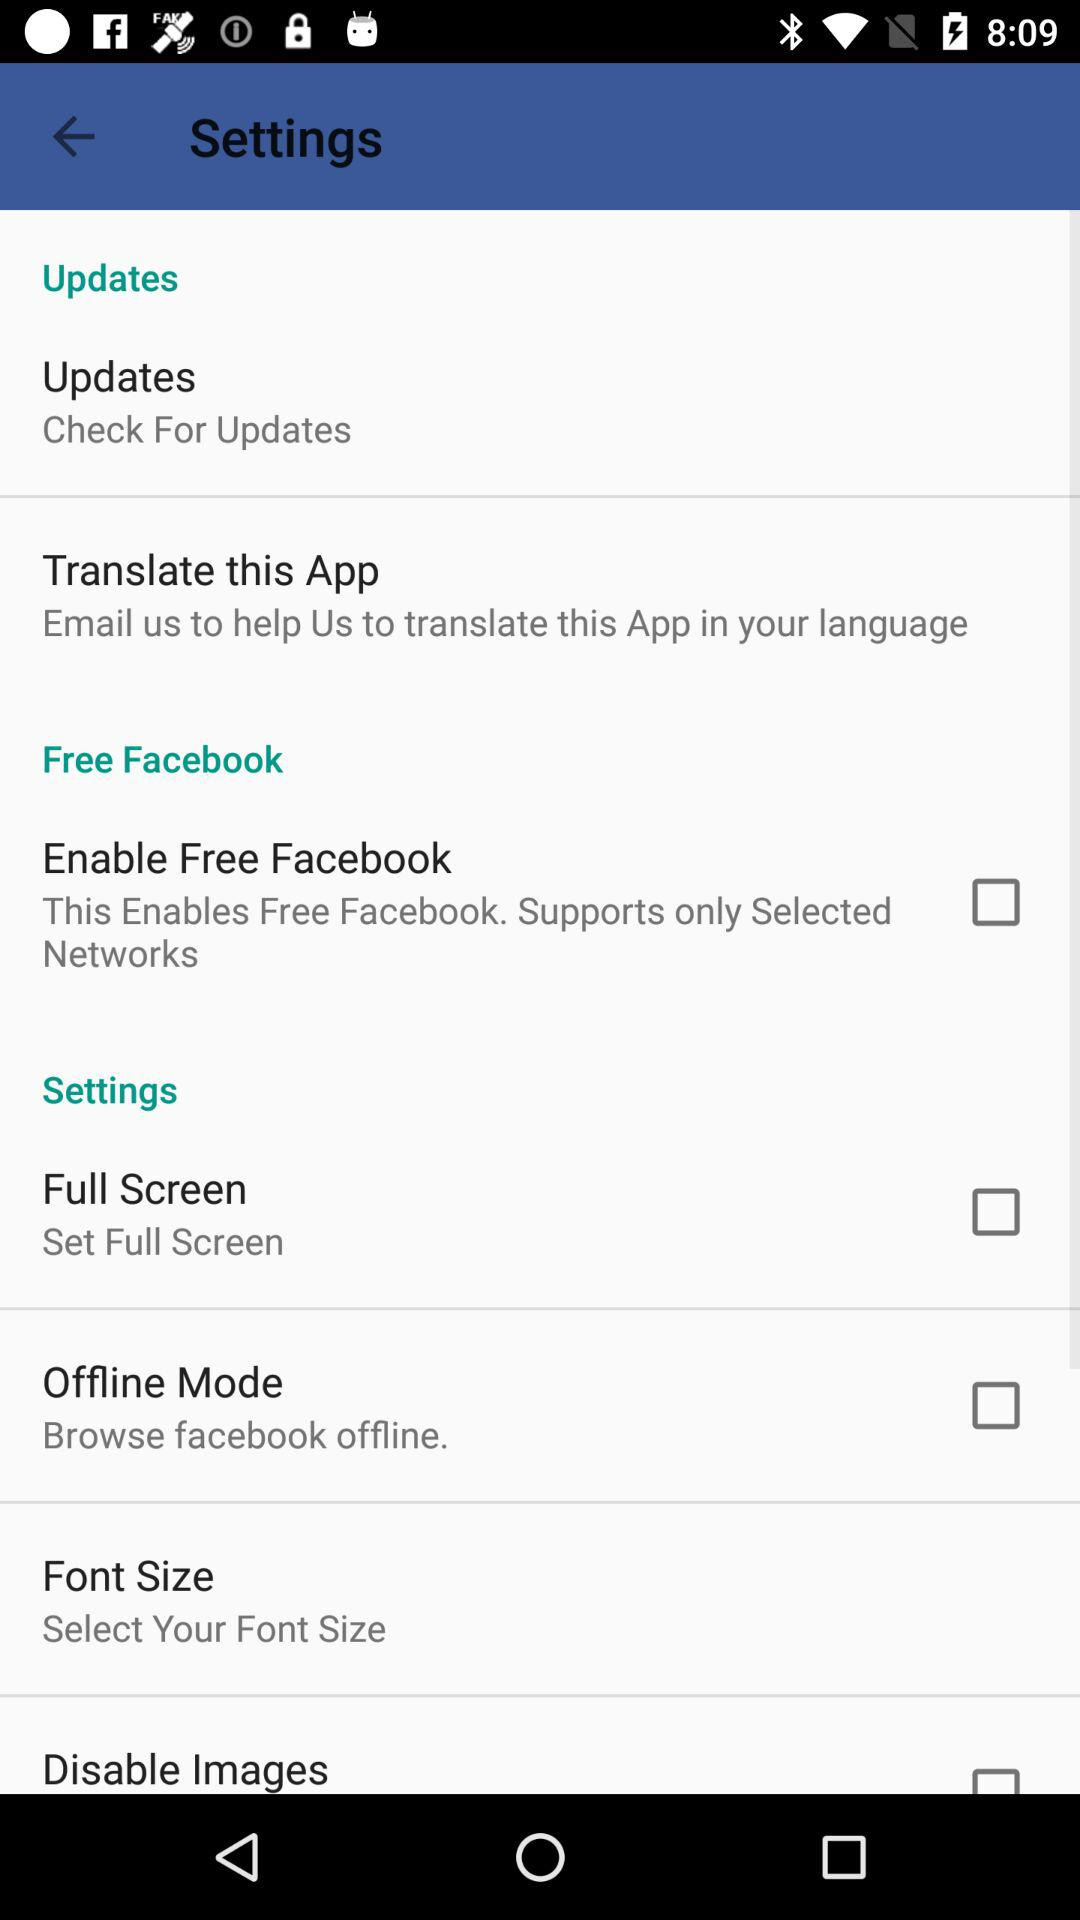What is the status of "Enable Free Facebook"? The status of "Enable Free Facebook" is "off". 